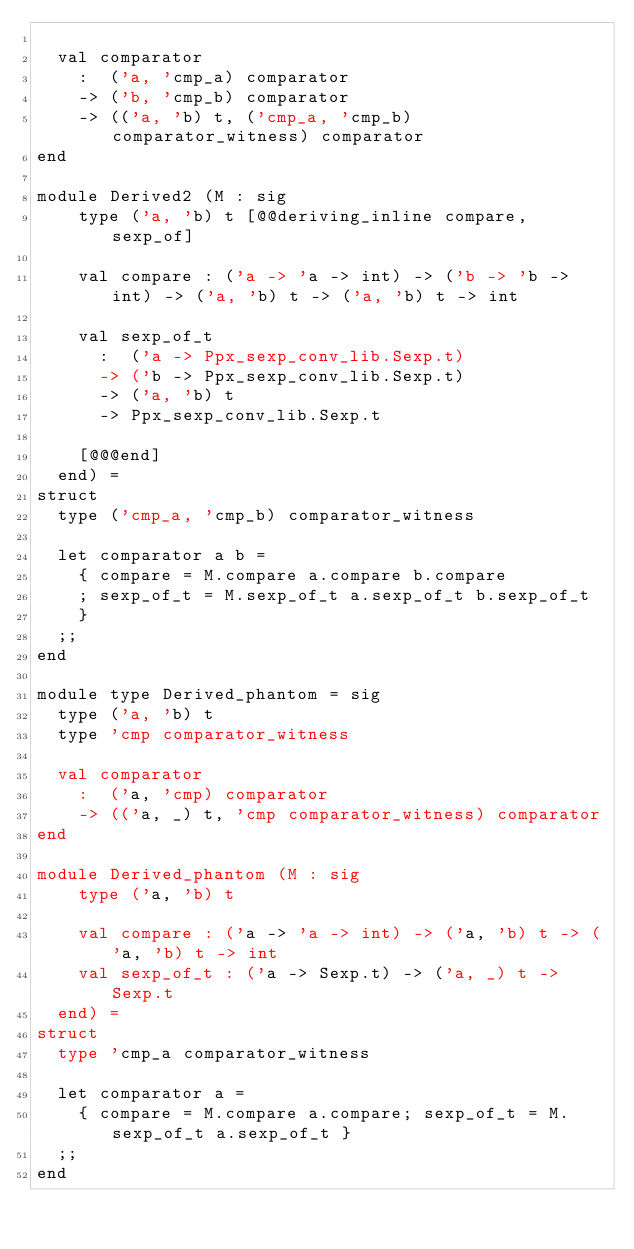<code> <loc_0><loc_0><loc_500><loc_500><_OCaml_>
  val comparator
    :  ('a, 'cmp_a) comparator
    -> ('b, 'cmp_b) comparator
    -> (('a, 'b) t, ('cmp_a, 'cmp_b) comparator_witness) comparator
end

module Derived2 (M : sig
    type ('a, 'b) t [@@deriving_inline compare, sexp_of]

    val compare : ('a -> 'a -> int) -> ('b -> 'b -> int) -> ('a, 'b) t -> ('a, 'b) t -> int

    val sexp_of_t
      :  ('a -> Ppx_sexp_conv_lib.Sexp.t)
      -> ('b -> Ppx_sexp_conv_lib.Sexp.t)
      -> ('a, 'b) t
      -> Ppx_sexp_conv_lib.Sexp.t

    [@@@end]
  end) =
struct
  type ('cmp_a, 'cmp_b) comparator_witness

  let comparator a b =
    { compare = M.compare a.compare b.compare
    ; sexp_of_t = M.sexp_of_t a.sexp_of_t b.sexp_of_t
    }
  ;;
end

module type Derived_phantom = sig
  type ('a, 'b) t
  type 'cmp comparator_witness

  val comparator
    :  ('a, 'cmp) comparator
    -> (('a, _) t, 'cmp comparator_witness) comparator
end

module Derived_phantom (M : sig
    type ('a, 'b) t

    val compare : ('a -> 'a -> int) -> ('a, 'b) t -> ('a, 'b) t -> int
    val sexp_of_t : ('a -> Sexp.t) -> ('a, _) t -> Sexp.t
  end) =
struct
  type 'cmp_a comparator_witness

  let comparator a =
    { compare = M.compare a.compare; sexp_of_t = M.sexp_of_t a.sexp_of_t }
  ;;
end
</code> 